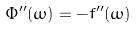<formula> <loc_0><loc_0><loc_500><loc_500>\Phi ^ { \prime \prime } ( \omega ) = - f ^ { \prime \prime } ( \omega )</formula> 